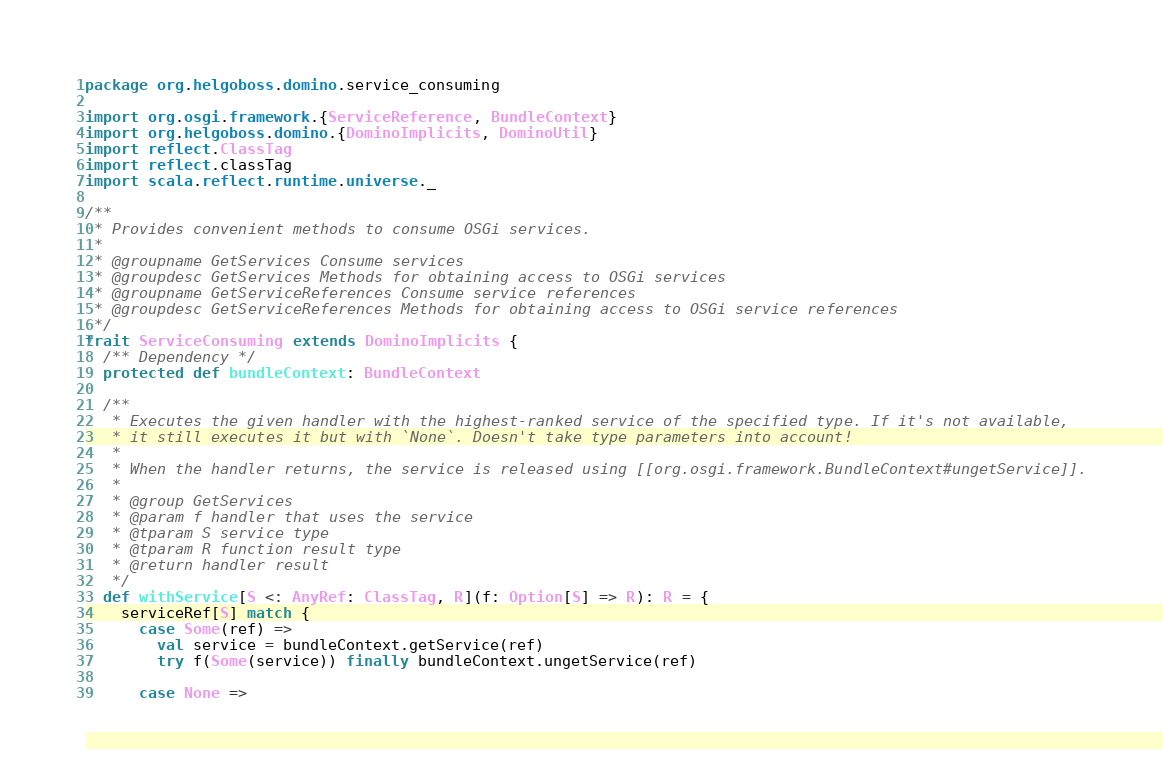<code> <loc_0><loc_0><loc_500><loc_500><_Scala_>package org.helgoboss.domino.service_consuming

import org.osgi.framework.{ServiceReference, BundleContext}
import org.helgoboss.domino.{DominoImplicits, DominoUtil}
import reflect.ClassTag
import reflect.classTag
import scala.reflect.runtime.universe._

/**
 * Provides convenient methods to consume OSGi services.
 *
 * @groupname GetServices Consume services
 * @groupdesc GetServices Methods for obtaining access to OSGi services
 * @groupname GetServiceReferences Consume service references
 * @groupdesc GetServiceReferences Methods for obtaining access to OSGi service references
 */
trait ServiceConsuming extends DominoImplicits {
  /** Dependency */
  protected def bundleContext: BundleContext

  /**
   * Executes the given handler with the highest-ranked service of the specified type. If it's not available,
   * it still executes it but with `None`. Doesn't take type parameters into account!
   *
   * When the handler returns, the service is released using [[org.osgi.framework.BundleContext#ungetService]].
   *
   * @group GetServices
   * @param f handler that uses the service
   * @tparam S service type
   * @tparam R function result type
   * @return handler result
   */
  def withService[S <: AnyRef: ClassTag, R](f: Option[S] => R): R = {
    serviceRef[S] match {
      case Some(ref) =>
        val service = bundleContext.getService(ref)
        try f(Some(service)) finally bundleContext.ungetService(ref)

      case None =></code> 